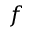Convert formula to latex. <formula><loc_0><loc_0><loc_500><loc_500>f</formula> 